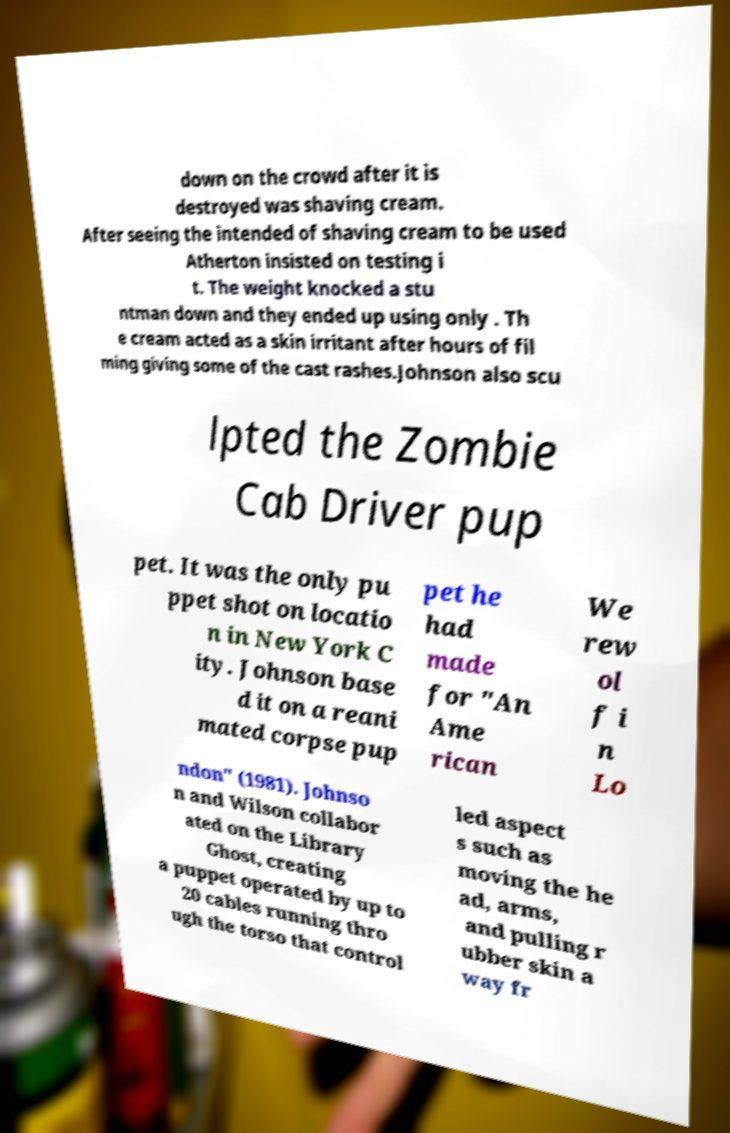For documentation purposes, I need the text within this image transcribed. Could you provide that? down on the crowd after it is destroyed was shaving cream. After seeing the intended of shaving cream to be used Atherton insisted on testing i t. The weight knocked a stu ntman down and they ended up using only . Th e cream acted as a skin irritant after hours of fil ming giving some of the cast rashes.Johnson also scu lpted the Zombie Cab Driver pup pet. It was the only pu ppet shot on locatio n in New York C ity. Johnson base d it on a reani mated corpse pup pet he had made for "An Ame rican We rew ol f i n Lo ndon" (1981). Johnso n and Wilson collabor ated on the Library Ghost, creating a puppet operated by up to 20 cables running thro ugh the torso that control led aspect s such as moving the he ad, arms, and pulling r ubber skin a way fr 